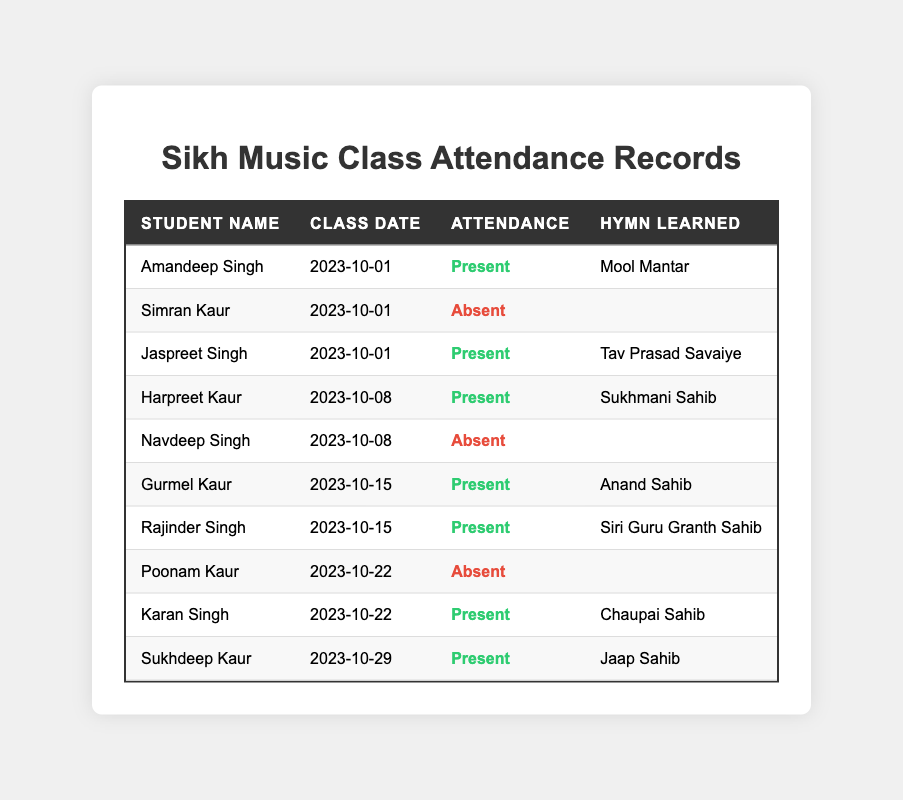What is the total number of students present in the class on October 1, 2023? There are three records for October 1, 2023. Among them, Amandeep Singh and Jaspreet Singh are marked as "Present", indicating that there are 2 students present.
Answer: 2 Which hymn did Gurmel Kaur learn? The table states that Gurmel Kaur attended class on October 15, 2023, and the hymn learned on that date is "Anand Sahib".
Answer: Anand Sahib How many students were absent on October 8, 2023? On October 8, 2023, there are two records: one for Harpreet Kaur marked "Present" and one for Navdeep Singh marked "Absent". Therefore, there is 1 student absent.
Answer: 1 Did Simran Kaur learn any hymn during her class on October 1, 2023? The table indicates that Simran Kaur was "Absent" on October 1, 2023, and there is no hymn learned recorded for her. Therefore, the answer is no.
Answer: No What percentage of students were present during the three class dates? There are 10 records total. Out of those, 7 students were present (Amandeep Singh, Jaspreet Singh, Harpreet Kaur, Gurmel Kaur, Rajinder Singh, Karan Singh, Sukhdeep Kaur). To find the percentage: (7/10) * 100 = 70%.
Answer: 70% How many different hymns have been learned by students with an attendance status of "Present"? The records indicate the following unique hymns learned by students present: Mool Mantar, Tav Prasad Savaiye, Sukhmani Sahib, Anand Sahib, Siri Guru Granth Sahib, Chaupai Sahib, Jaap Sahib. This gives us a total of 7 different hymns.
Answer: 7 Which student has the most recent class date recorded and what hymn did they learn? The most recent class date in the records is October 29, 2023, which corresponds to Sukhdeep Kaur. The hymn learned on that date is "Jaap Sahib".
Answer: Sukhdeep Kaur, Jaap Sahib Was there any class date in October 2023 when all students were present? Review the class dates: - October 1: 2 Present, 1 Absent - October 8: 1 Present, 1 Absent - October 15: 2 Present, 0 Absent - October 22: 1 Present, 1 Absent - October 29: 1 Present. Therefore, no class date had all students present.
Answer: No What is the ratio of present students to absent students across all classes? There are 7 students present and 3 students absent in total. To find the ratio: 7 present to 3 absent simplifies to 7:3.
Answer: 7:3 How many students learned the hymn "Chaupai Sahib"? From the table, Karan Singh is the only student recorded to have learned "Chaupai Sahib" on October 22, 2023. Therefore, only 1 student learned this hymn.
Answer: 1 Identify the student who was present on both October 15 and October 22, 2023. The records show that Gurmel Kaur was present on October 15 and Karan Singh was present on October 22. No student is listed as present for both dates, making it impossible to identify a student.
Answer: No student 